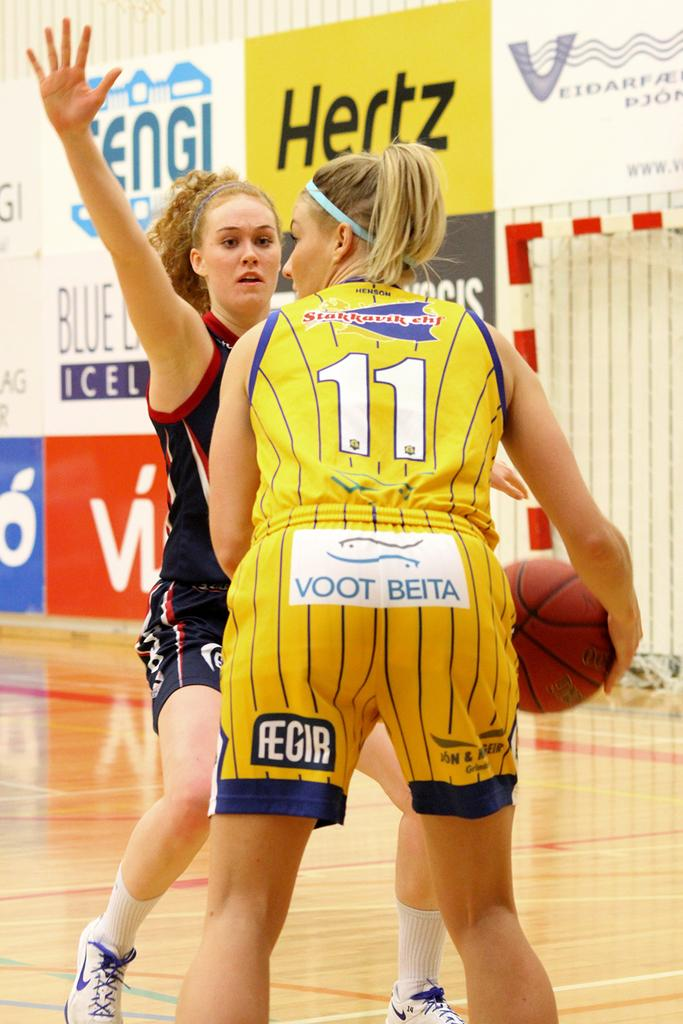Provide a one-sentence caption for the provided image. Two female basketball players, one in yellow shorts reading VOOT BEITA, go head to head during a game. 